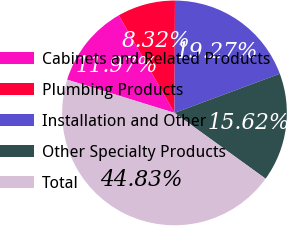Convert chart to OTSL. <chart><loc_0><loc_0><loc_500><loc_500><pie_chart><fcel>Cabinets and Related Products<fcel>Plumbing Products<fcel>Installation and Other<fcel>Other Specialty Products<fcel>Total<nl><fcel>11.97%<fcel>8.32%<fcel>19.27%<fcel>15.62%<fcel>44.83%<nl></chart> 